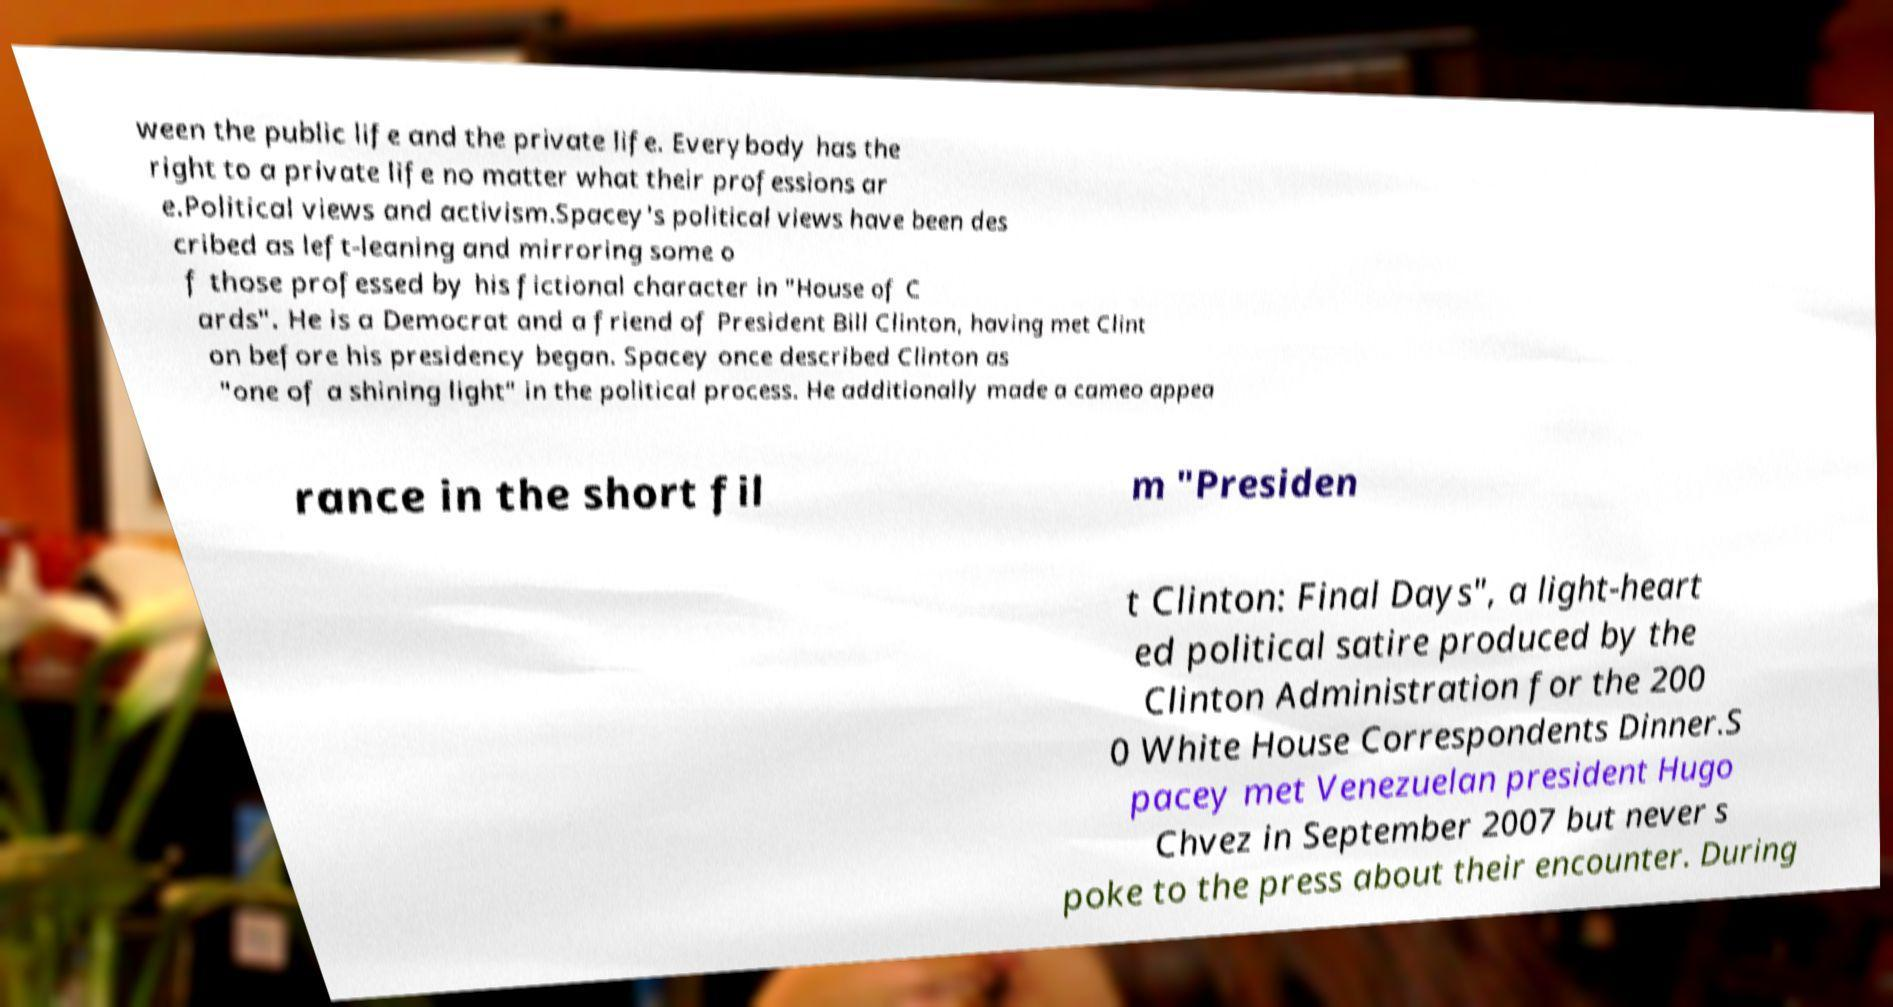What messages or text are displayed in this image? I need them in a readable, typed format. ween the public life and the private life. Everybody has the right to a private life no matter what their professions ar e.Political views and activism.Spacey's political views have been des cribed as left-leaning and mirroring some o f those professed by his fictional character in "House of C ards". He is a Democrat and a friend of President Bill Clinton, having met Clint on before his presidency began. Spacey once described Clinton as "one of a shining light" in the political process. He additionally made a cameo appea rance in the short fil m "Presiden t Clinton: Final Days", a light-heart ed political satire produced by the Clinton Administration for the 200 0 White House Correspondents Dinner.S pacey met Venezuelan president Hugo Chvez in September 2007 but never s poke to the press about their encounter. During 